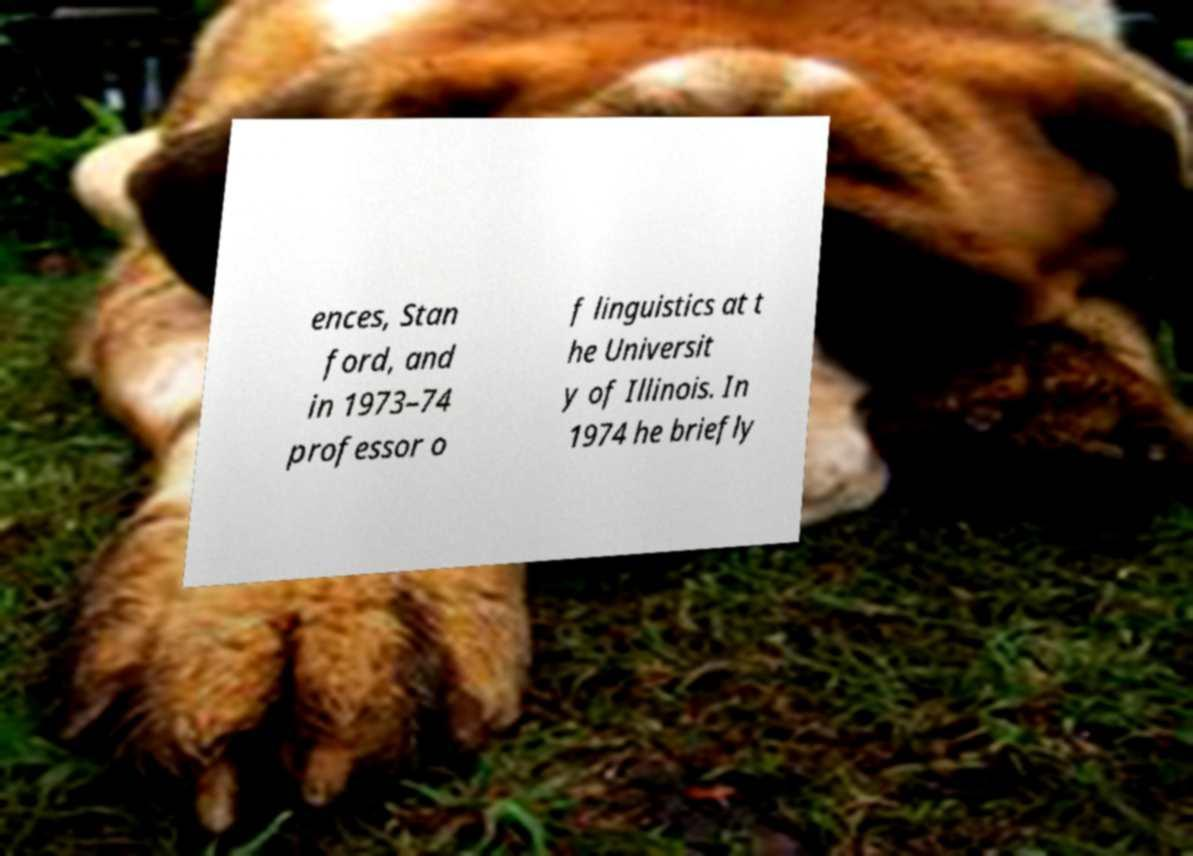Please identify and transcribe the text found in this image. ences, Stan ford, and in 1973–74 professor o f linguistics at t he Universit y of Illinois. In 1974 he briefly 